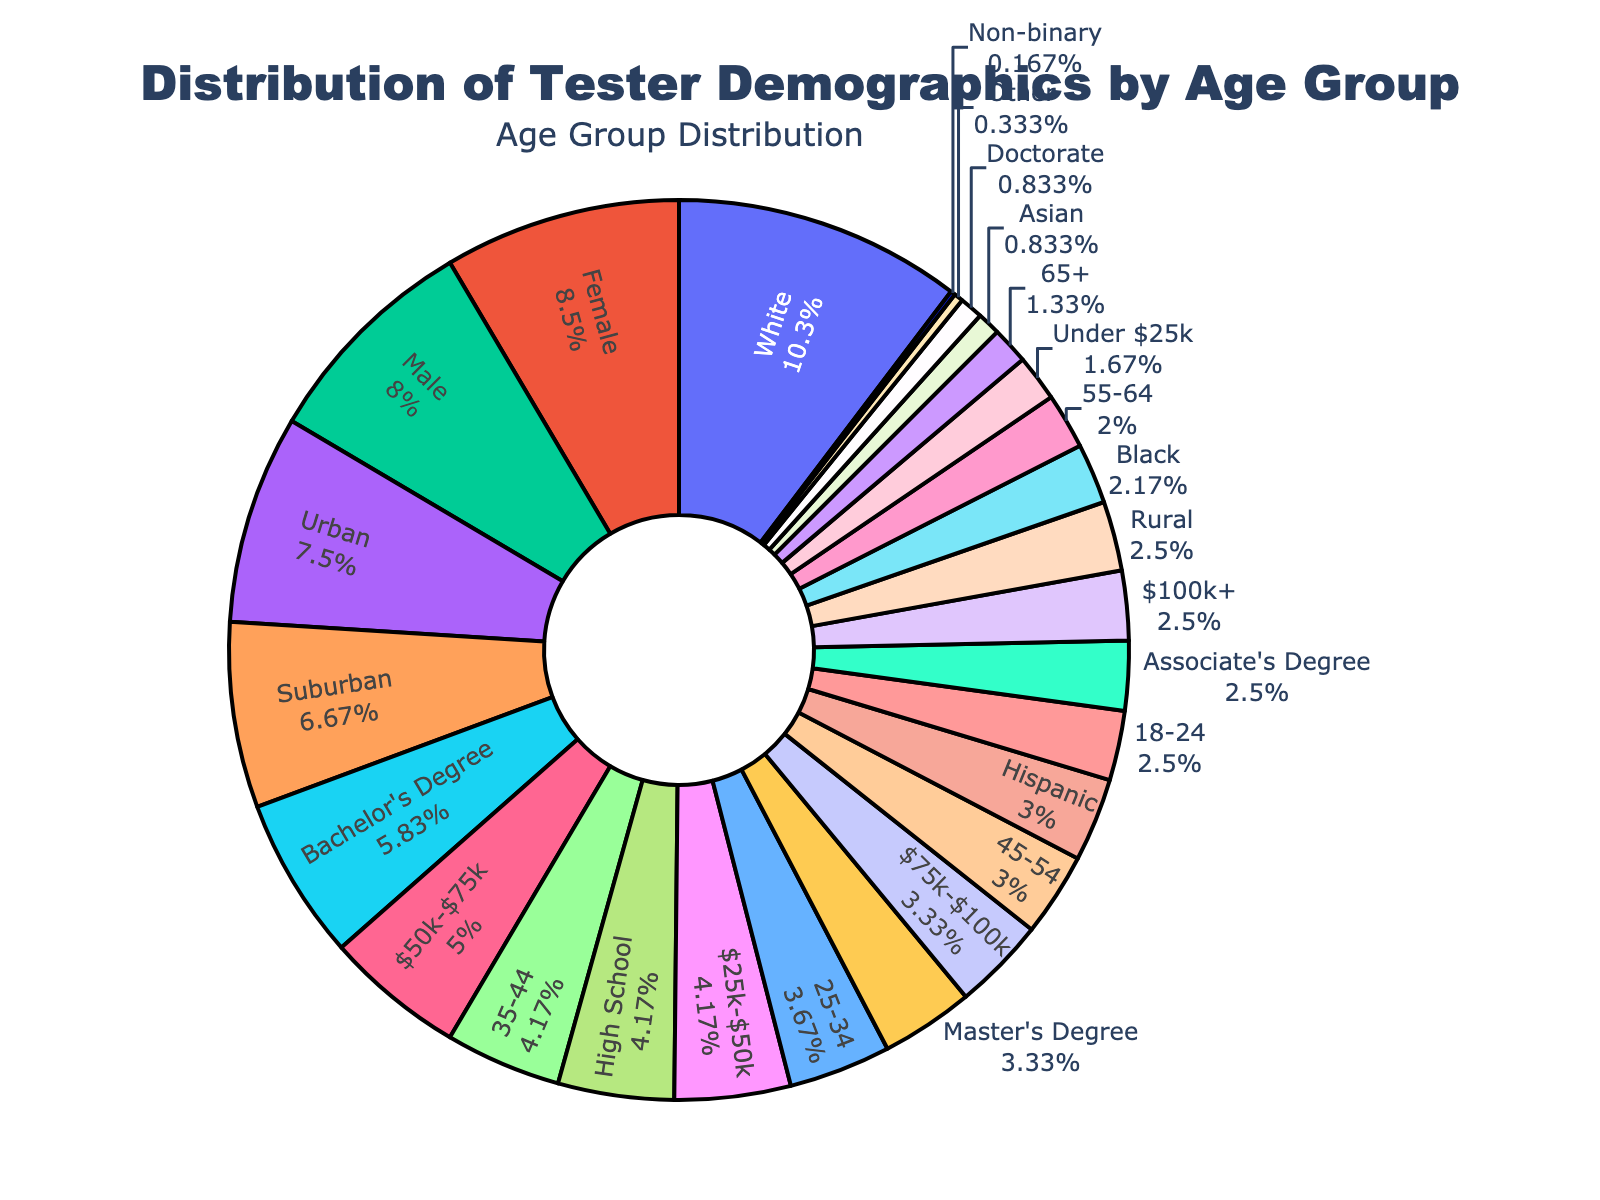What is the largest age group in the tester demographics? To find the largest age group, look at the section in the pie chart that occupies the most space. The largest portion is represented by the "35-44" age group.
Answer: 35-44 Which age groups make up more than 20% of the demographics each? Identify the age groups whose pie chart sections represent more than 20% of the whole. These are "25-34" and "35-44" groups.
Answer: 25-34 and 35-44 What is the difference in percentage between the "18-24" and "25-34" age groups? Subtract the percentage of the "18-24" age group from the "25-34" age group: 22% (25-34) - 15% (18-24) = 7%.
Answer: 7% Calculate the combined percentage of testers aged 45 and above. Add the percentages of the "45-54", "55-64", and "65+" age groups: 18% + 12% + 8% = 38%.
Answer: 38% Which age group has the smallest representation, and how much is it? Look for the smallest section of the pie chart, which is the "65+" age group with 8%.
Answer: 65+, 8% What is the total percentage of testers under 35 years old? Add the percentages of the "18-24" and "25-34" age groups: 15% + 22% = 37%.
Answer: 37% Is the percentage of testers aged 25-34 greater than that of testers aged 45-54? Compare the two percentages: 22% (25-34) > 18% (45-54).
Answer: Yes Which age groups are represented in shades of blue, and what are their percentages? Identify the shades of blue in the pie chart, which are associated with certain age groups: "25-34" (22%) and "55-64" (12%).
Answer: 25-34 (22%), 55-64 (12%) How much more (in percentage) is the representation of the "35-44" age group compared to "55-64"? Subtract the percentage of the "55-64" age group from the "35-44" age group: 25% (35-44) - 12% (55-64) = 13%.
Answer: 13% What percentage of testers fall into the categories with less than 15% representation each? Find the age groups with less than 15% and sum their percentages: "18-24" (15%), "55-64" (12%), and "65+" (8%). Adding these gives: 15% + 12% + 8% = 35%.
Answer: 35% 